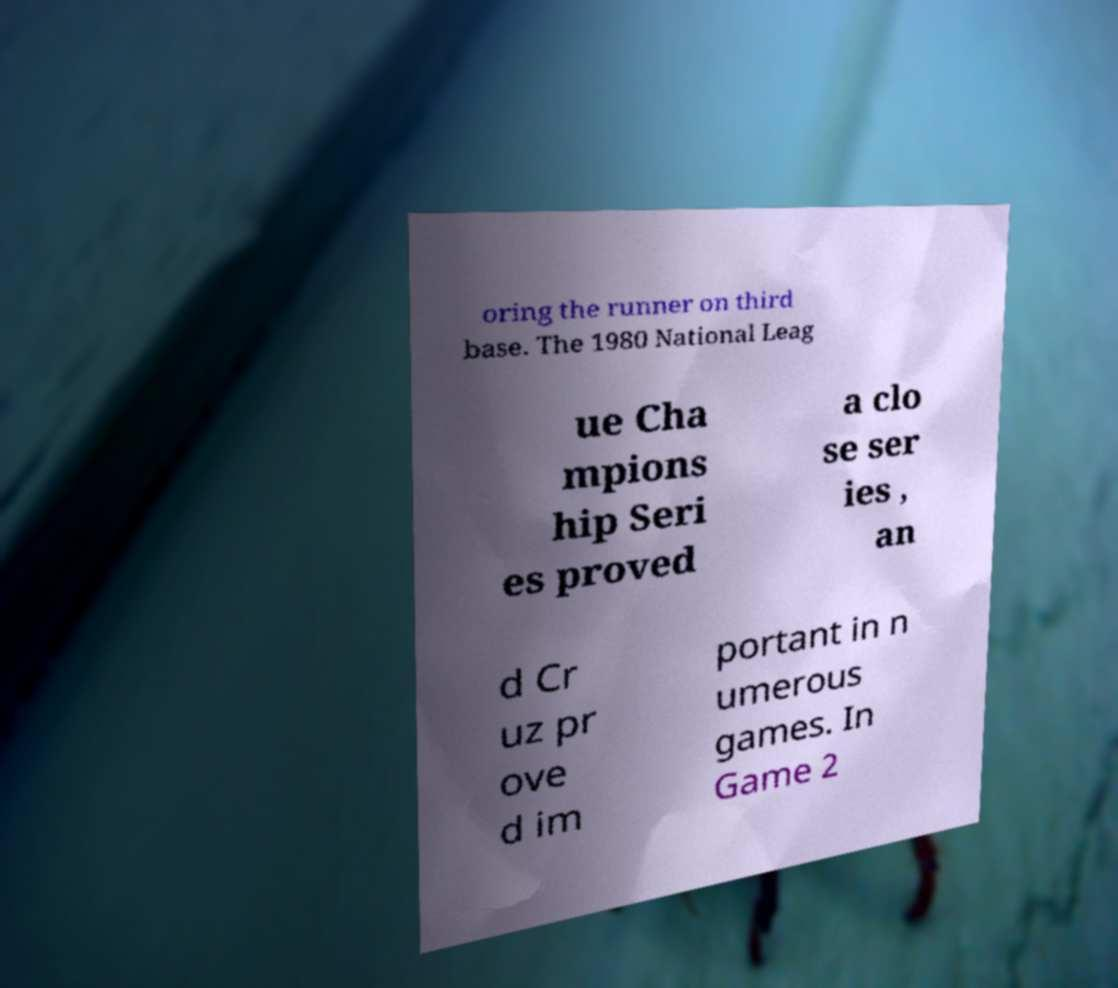Can you read and provide the text displayed in the image?This photo seems to have some interesting text. Can you extract and type it out for me? oring the runner on third base. The 1980 National Leag ue Cha mpions hip Seri es proved a clo se ser ies , an d Cr uz pr ove d im portant in n umerous games. In Game 2 